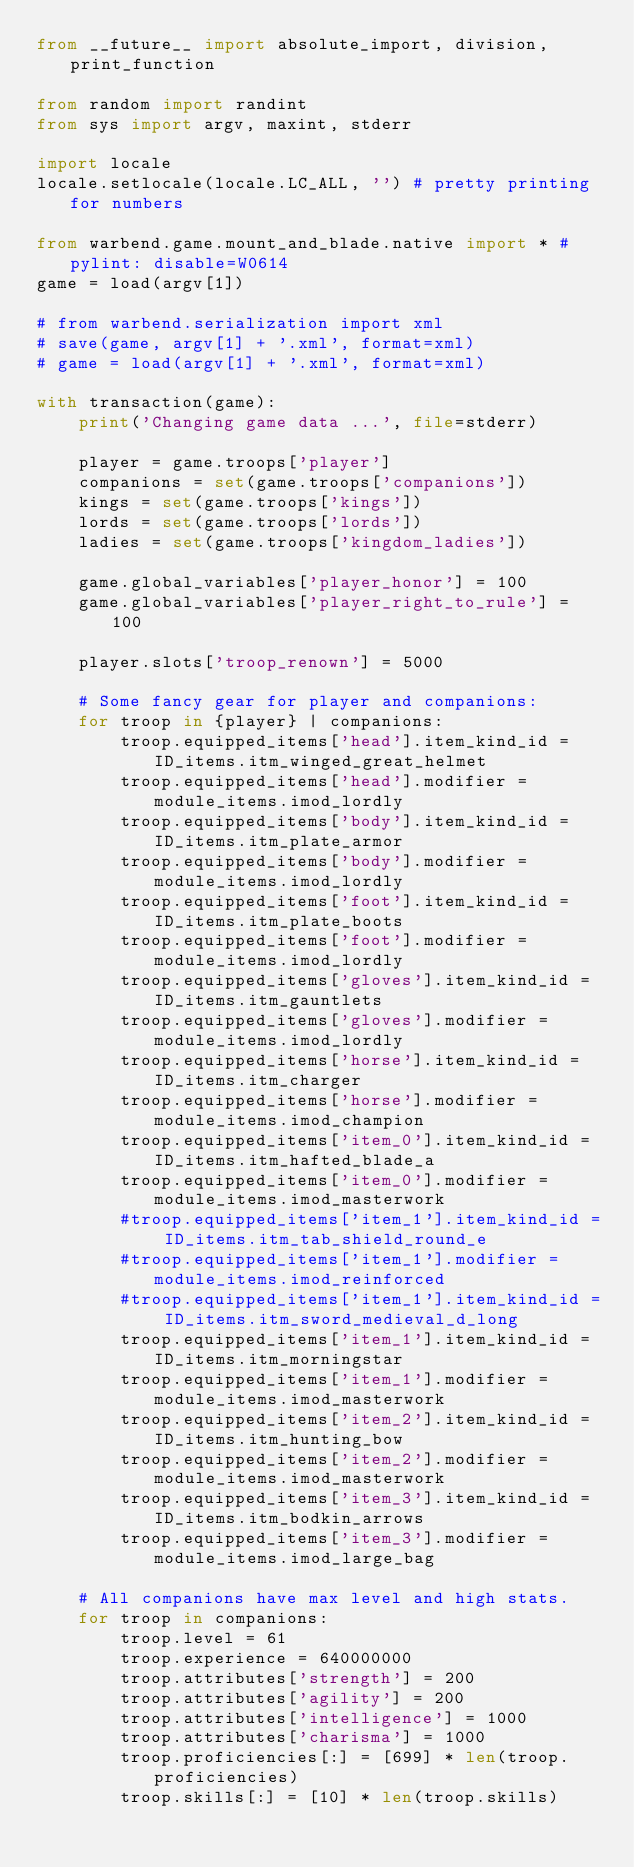<code> <loc_0><loc_0><loc_500><loc_500><_Python_>from __future__ import absolute_import, division, print_function

from random import randint
from sys import argv, maxint, stderr

import locale
locale.setlocale(locale.LC_ALL, '') # pretty printing for numbers

from warbend.game.mount_and_blade.native import * # pylint: disable=W0614
game = load(argv[1])

# from warbend.serialization import xml
# save(game, argv[1] + '.xml', format=xml)
# game = load(argv[1] + '.xml', format=xml)

with transaction(game):
    print('Changing game data ...', file=stderr)

    player = game.troops['player']
    companions = set(game.troops['companions'])
    kings = set(game.troops['kings'])
    lords = set(game.troops['lords'])
    ladies = set(game.troops['kingdom_ladies'])

    game.global_variables['player_honor'] = 100
    game.global_variables['player_right_to_rule'] = 100

    player.slots['troop_renown'] = 5000

    # Some fancy gear for player and companions:
    for troop in {player} | companions:
        troop.equipped_items['head'].item_kind_id = ID_items.itm_winged_great_helmet
        troop.equipped_items['head'].modifier = module_items.imod_lordly
        troop.equipped_items['body'].item_kind_id = ID_items.itm_plate_armor
        troop.equipped_items['body'].modifier = module_items.imod_lordly
        troop.equipped_items['foot'].item_kind_id = ID_items.itm_plate_boots
        troop.equipped_items['foot'].modifier = module_items.imod_lordly
        troop.equipped_items['gloves'].item_kind_id = ID_items.itm_gauntlets
        troop.equipped_items['gloves'].modifier = module_items.imod_lordly
        troop.equipped_items['horse'].item_kind_id = ID_items.itm_charger
        troop.equipped_items['horse'].modifier = module_items.imod_champion
        troop.equipped_items['item_0'].item_kind_id = ID_items.itm_hafted_blade_a
        troop.equipped_items['item_0'].modifier = module_items.imod_masterwork
        #troop.equipped_items['item_1'].item_kind_id = ID_items.itm_tab_shield_round_e
        #troop.equipped_items['item_1'].modifier = module_items.imod_reinforced
        #troop.equipped_items['item_1'].item_kind_id = ID_items.itm_sword_medieval_d_long
        troop.equipped_items['item_1'].item_kind_id = ID_items.itm_morningstar
        troop.equipped_items['item_1'].modifier = module_items.imod_masterwork
        troop.equipped_items['item_2'].item_kind_id = ID_items.itm_hunting_bow
        troop.equipped_items['item_2'].modifier = module_items.imod_masterwork
        troop.equipped_items['item_3'].item_kind_id = ID_items.itm_bodkin_arrows
        troop.equipped_items['item_3'].modifier = module_items.imod_large_bag

    # All companions have max level and high stats.
    for troop in companions:
        troop.level = 61
        troop.experience = 640000000
        troop.attributes['strength'] = 200
        troop.attributes['agility'] = 200
        troop.attributes['intelligence'] = 1000
        troop.attributes['charisma'] = 1000
        troop.proficiencies[:] = [699] * len(troop.proficiencies)
        troop.skills[:] = [10] * len(troop.skills)
</code> 